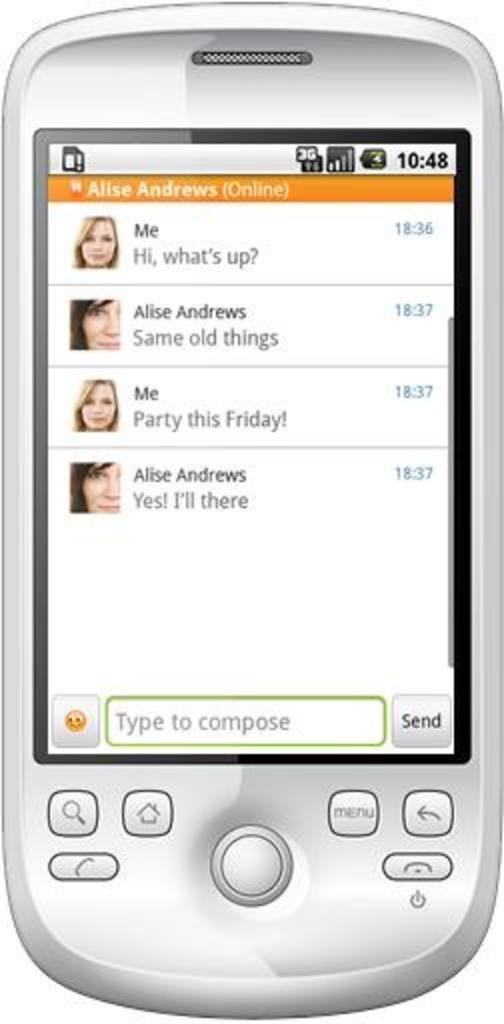<image>
Provide a brief description of the given image. An image of a smartphone with various texts on the screen, one reads "party this Friday!" 